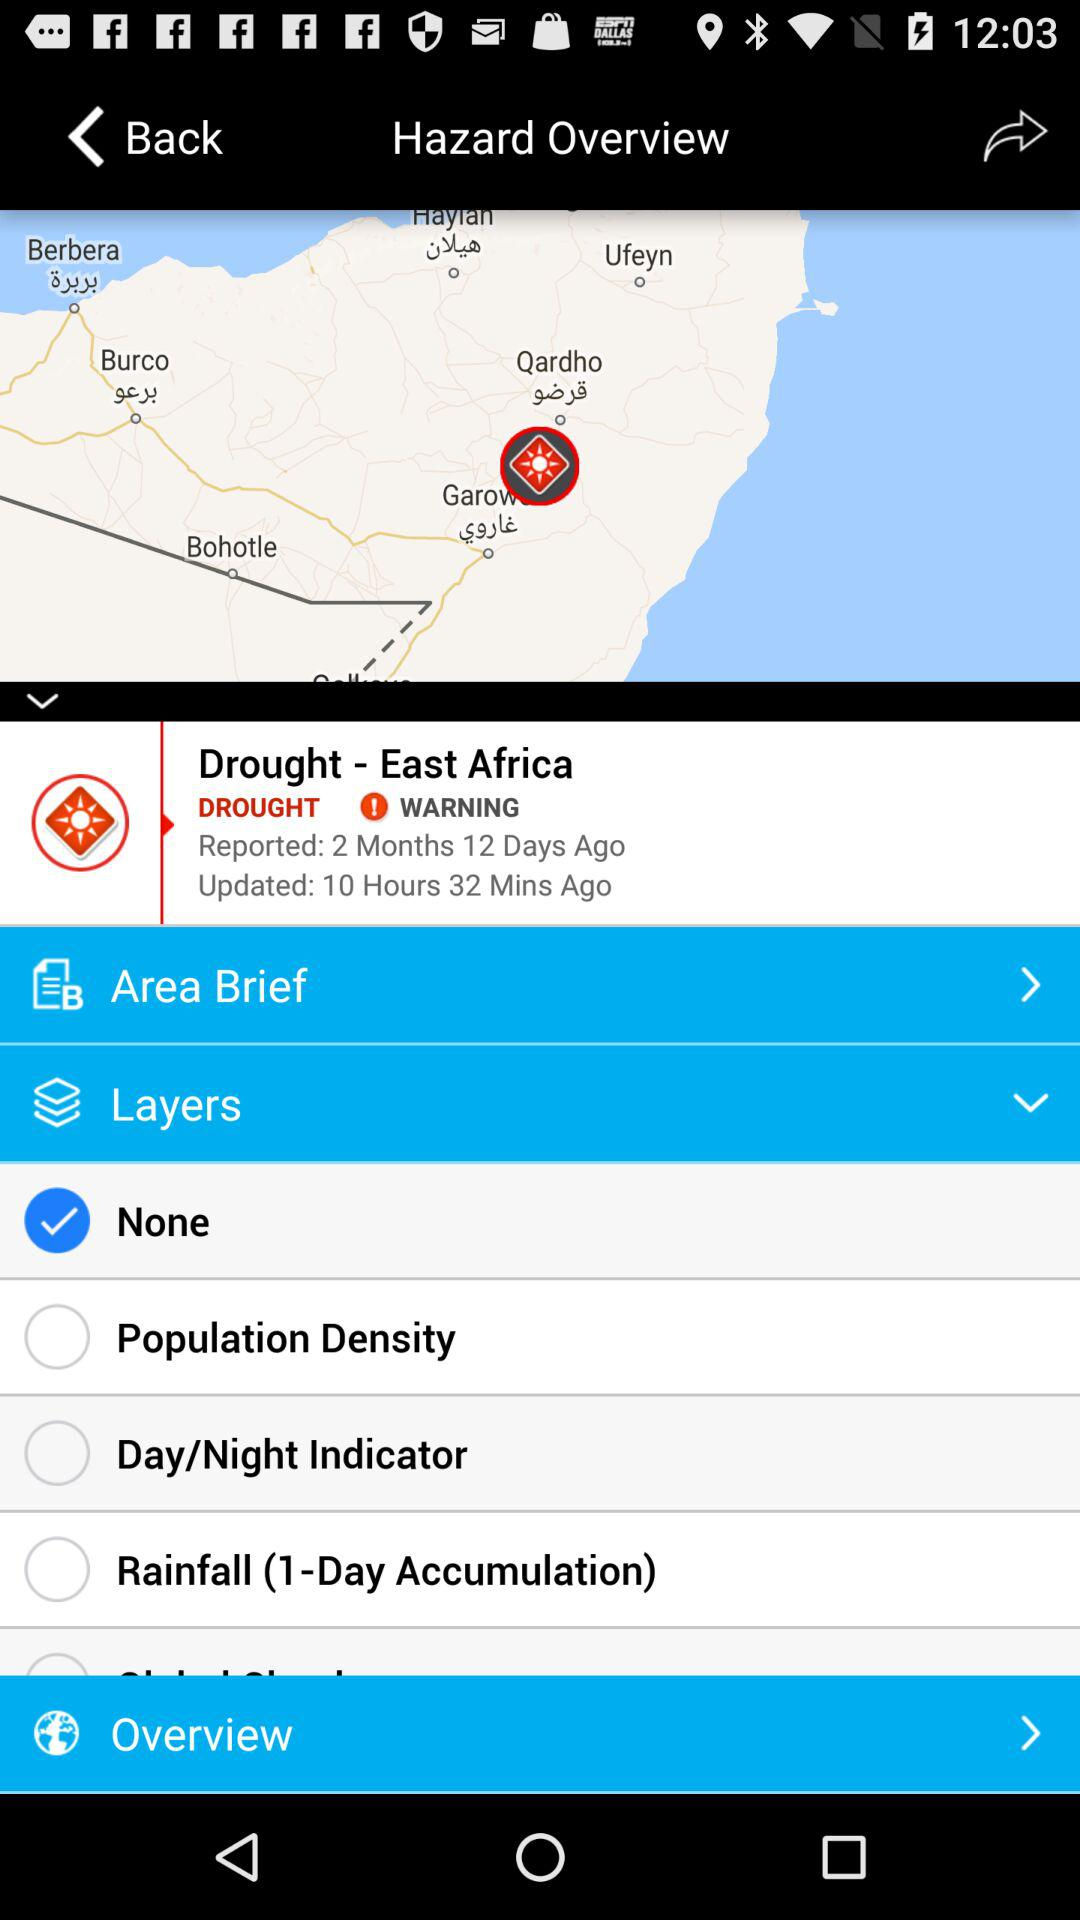What is the mentioned region of Africa? The mentioned region is "East Africa". 